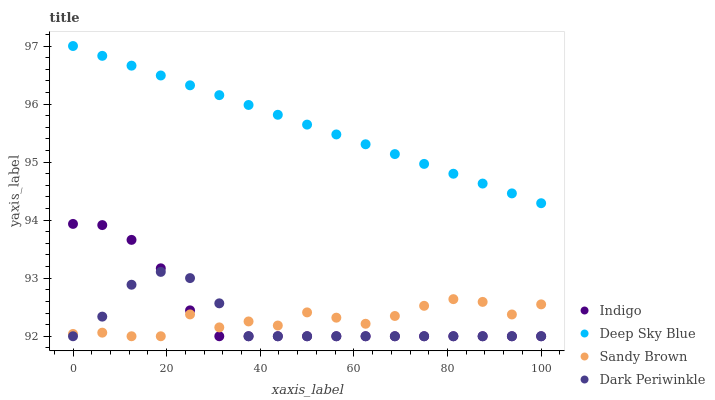Does Dark Periwinkle have the minimum area under the curve?
Answer yes or no. Yes. Does Deep Sky Blue have the maximum area under the curve?
Answer yes or no. Yes. Does Indigo have the minimum area under the curve?
Answer yes or no. No. Does Indigo have the maximum area under the curve?
Answer yes or no. No. Is Deep Sky Blue the smoothest?
Answer yes or no. Yes. Is Sandy Brown the roughest?
Answer yes or no. Yes. Is Indigo the smoothest?
Answer yes or no. No. Is Indigo the roughest?
Answer yes or no. No. Does Sandy Brown have the lowest value?
Answer yes or no. Yes. Does Deep Sky Blue have the lowest value?
Answer yes or no. No. Does Deep Sky Blue have the highest value?
Answer yes or no. Yes. Does Indigo have the highest value?
Answer yes or no. No. Is Indigo less than Deep Sky Blue?
Answer yes or no. Yes. Is Deep Sky Blue greater than Indigo?
Answer yes or no. Yes. Does Dark Periwinkle intersect Sandy Brown?
Answer yes or no. Yes. Is Dark Periwinkle less than Sandy Brown?
Answer yes or no. No. Is Dark Periwinkle greater than Sandy Brown?
Answer yes or no. No. Does Indigo intersect Deep Sky Blue?
Answer yes or no. No. 